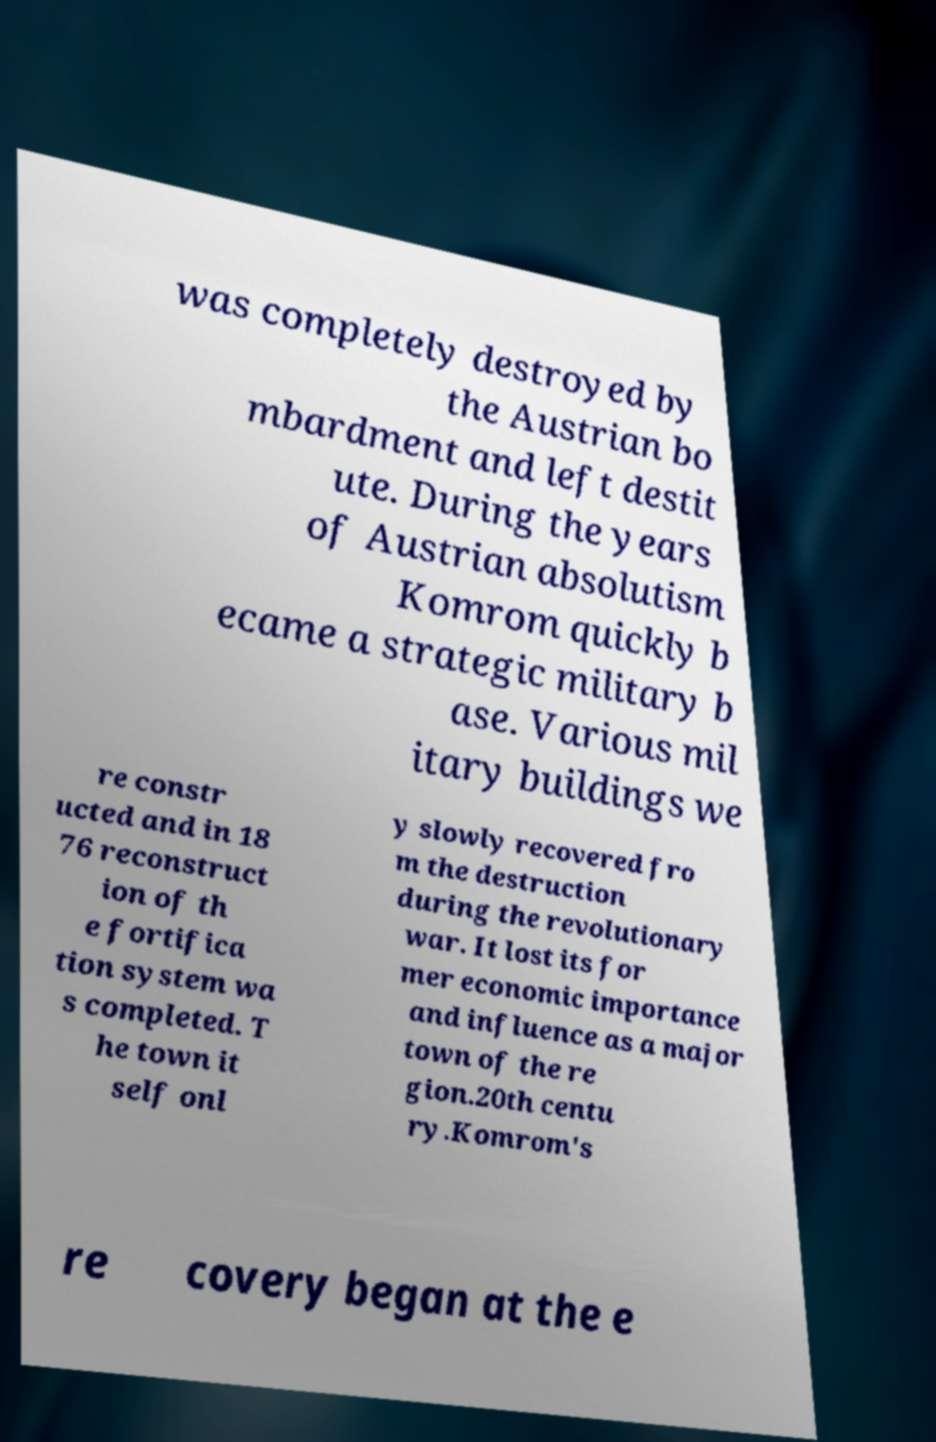Please read and relay the text visible in this image. What does it say? was completely destroyed by the Austrian bo mbardment and left destit ute. During the years of Austrian absolutism Komrom quickly b ecame a strategic military b ase. Various mil itary buildings we re constr ucted and in 18 76 reconstruct ion of th e fortifica tion system wa s completed. T he town it self onl y slowly recovered fro m the destruction during the revolutionary war. It lost its for mer economic importance and influence as a major town of the re gion.20th centu ry.Komrom's re covery began at the e 